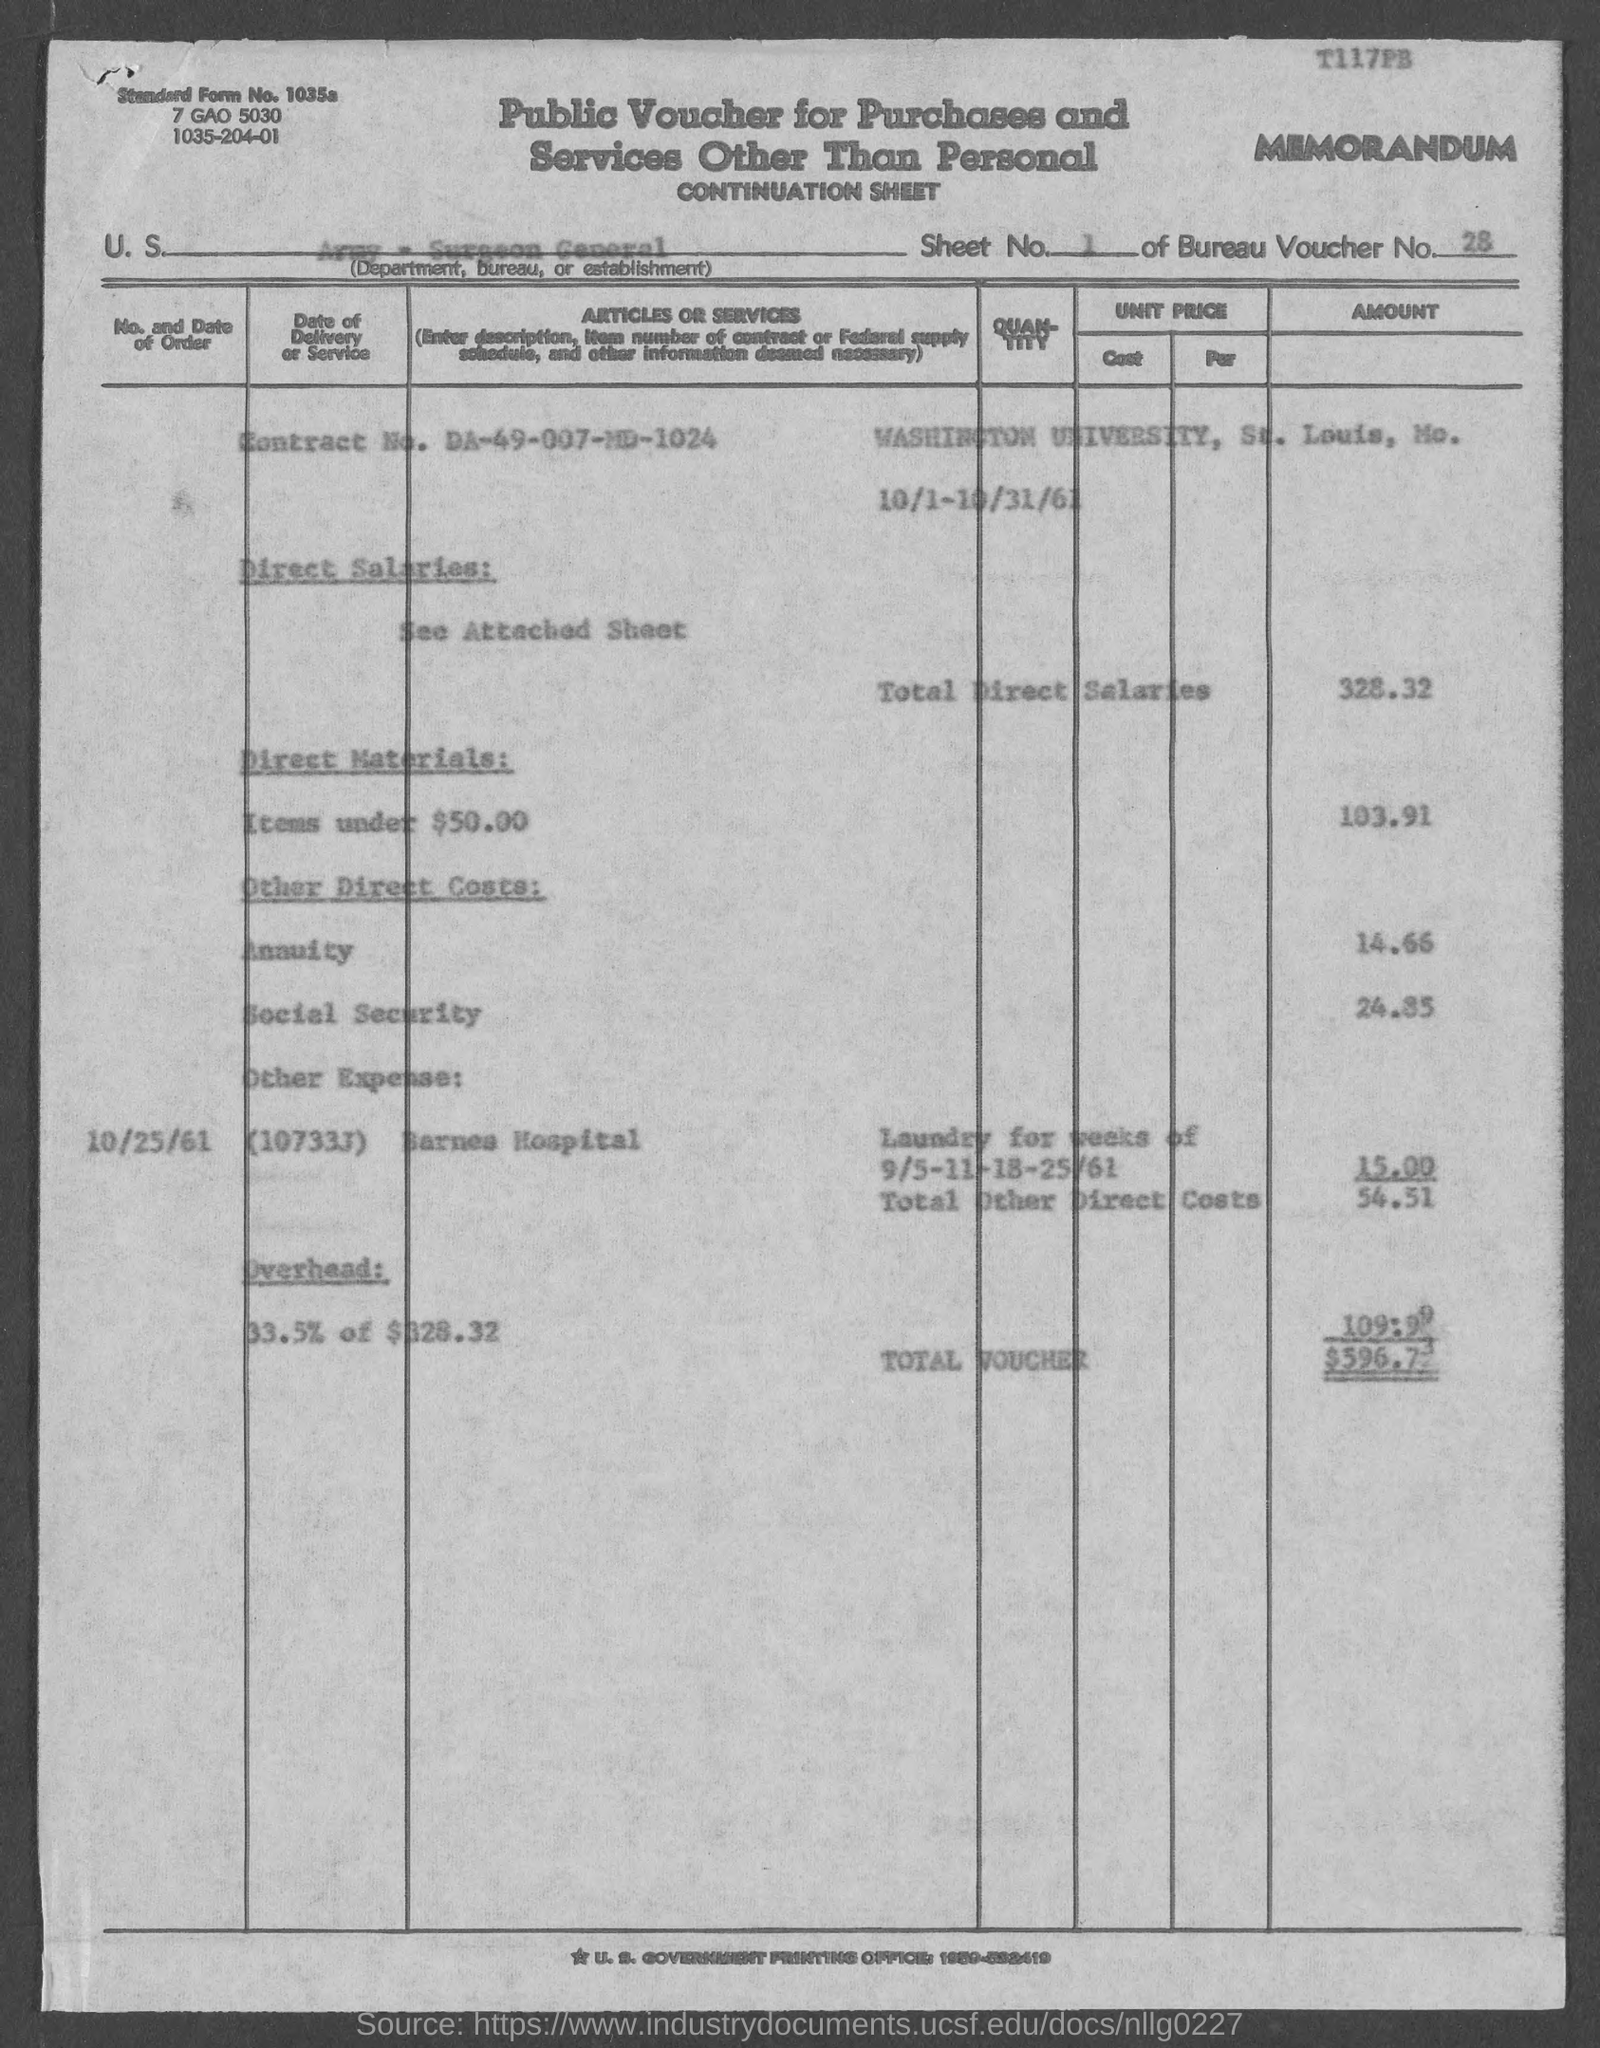Which U.S. Department, Bureau, or Establishment is mentioned in the voucher?
Ensure brevity in your answer.  Army - Surgeon General. What is the Sheet No. mentioned in the voucher?
Make the answer very short. 1. What is the Bureau Voucher No. given in the document?
Give a very brief answer. 28. What is the Contract No. given in the voucher?
Offer a very short reply. DA-49-007-MD-1024. What is the direct salaries cost mentioned in the voucher?
Ensure brevity in your answer.  328.32. What is the Direct materials cost (Items under $50) given in the voucher?
Keep it short and to the point. 103.91. What is the total other direct costs mentioned in the voucher?
Your answer should be compact. 54.51. What is the total amount mentioned in the voucher?
Offer a terse response. 596.73. What is the Standard Form No. given in the voucher?
Keep it short and to the point. 1035a. 